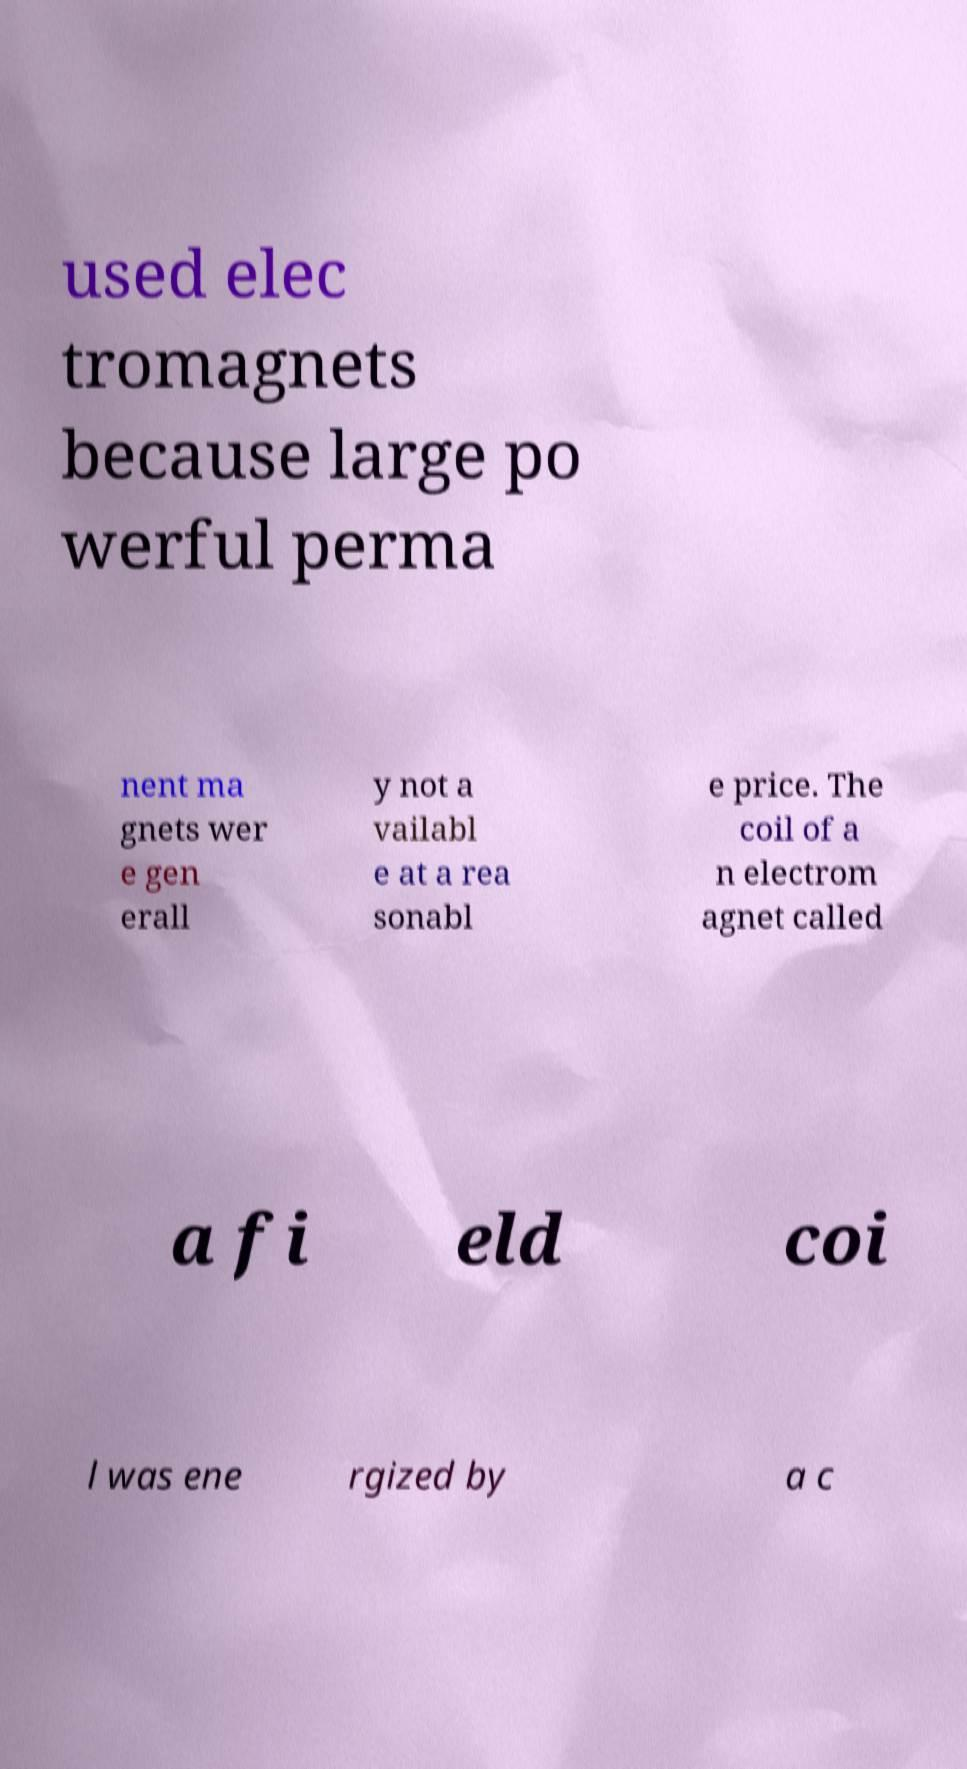What messages or text are displayed in this image? I need them in a readable, typed format. used elec tromagnets because large po werful perma nent ma gnets wer e gen erall y not a vailabl e at a rea sonabl e price. The coil of a n electrom agnet called a fi eld coi l was ene rgized by a c 